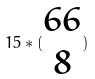<formula> <loc_0><loc_0><loc_500><loc_500>1 5 * ( \begin{matrix} 6 6 \\ 8 \end{matrix} )</formula> 